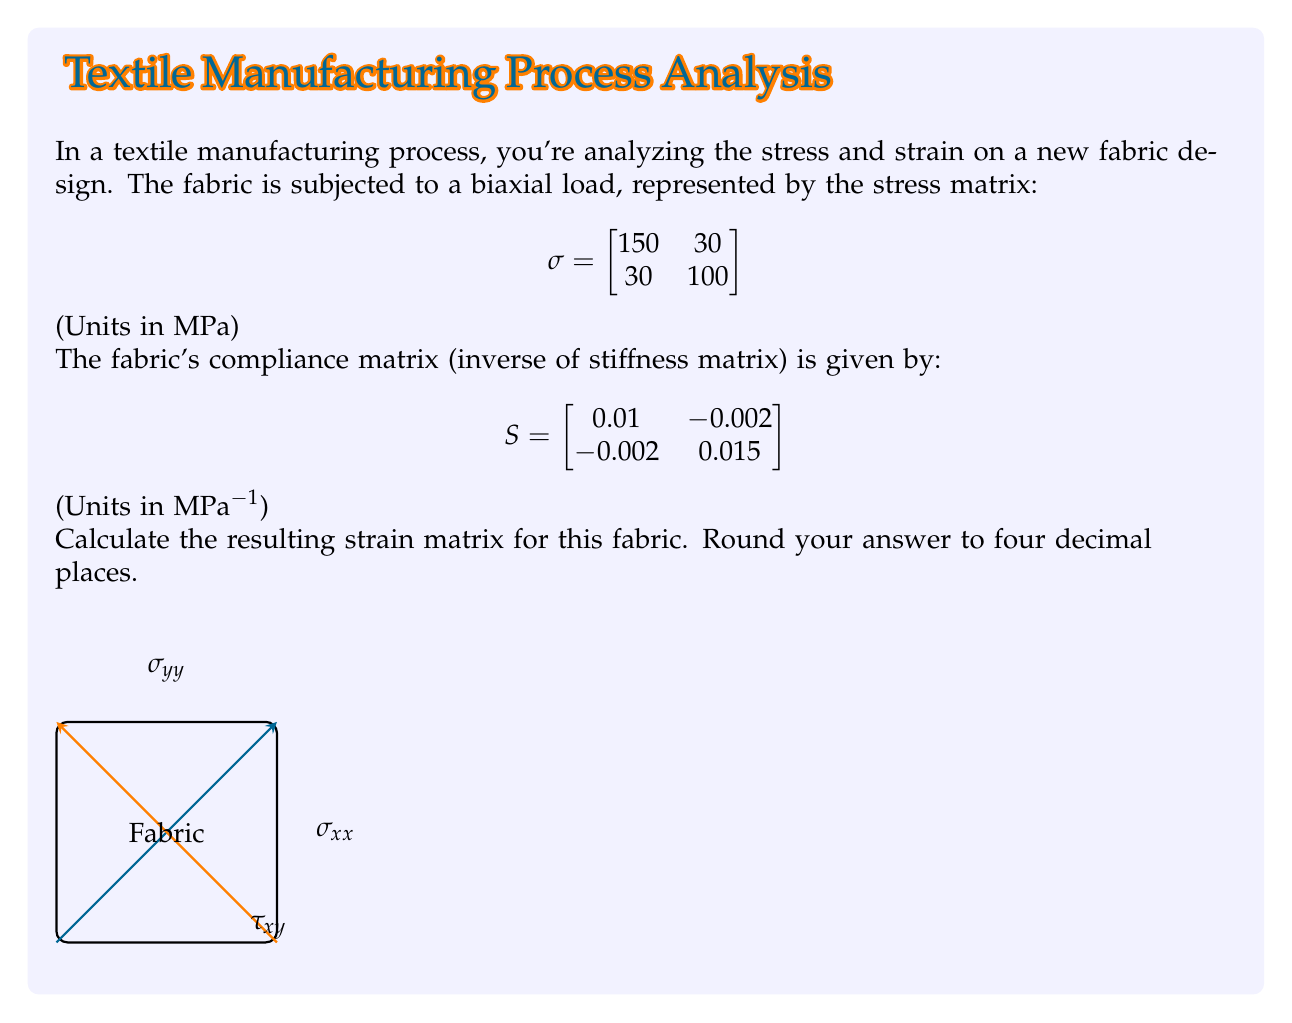Provide a solution to this math problem. To solve this problem, we'll use the fundamental relationship between stress and strain in matrix mechanics:

$$\varepsilon = S \cdot \sigma$$

Where:
$\varepsilon$ is the strain matrix
$S$ is the compliance matrix
$\sigma$ is the stress matrix

Steps:

1) We have the stress matrix $\sigma$ and the compliance matrix $S$. We need to multiply these matrices to get the strain matrix $\varepsilon$.

2) Multiply the matrices:

$$\varepsilon = \begin{bmatrix}
0.01 & -0.002 \\
-0.002 & 0.015
\end{bmatrix} \cdot \begin{bmatrix}
150 & 30 \\
30 & 100
\end{bmatrix}$$

3) Perform the matrix multiplication:

$$\varepsilon_{11} = (0.01 \cdot 150) + (-0.002 \cdot 30) = 1.5 - 0.06 = 1.44$$
$$\varepsilon_{12} = (0.01 \cdot 30) + (-0.002 \cdot 100) = 0.3 - 0.2 = 0.1$$
$$\varepsilon_{21} = (-0.002 \cdot 150) + (0.015 \cdot 30) = -0.3 + 0.45 = 0.15$$
$$\varepsilon_{22} = (-0.002 \cdot 30) + (0.015 \cdot 100) = -0.06 + 1.5 = 1.44$$

4) Construct the resulting strain matrix:

$$\varepsilon = \begin{bmatrix}
1.44 & 0.1 \\
0.15 & 1.44
\end{bmatrix}$$

5) Rounding to four decimal places:

$$\varepsilon = \begin{bmatrix}
1.4400 & 0.1000 \\
0.1500 & 1.4400
\end{bmatrix}$$

This strain matrix represents the deformation of the fabric under the given stress conditions.
Answer: $$\varepsilon = \begin{bmatrix}
1.4400 & 0.1000 \\
0.1500 & 1.4400
\end{bmatrix}$$ 